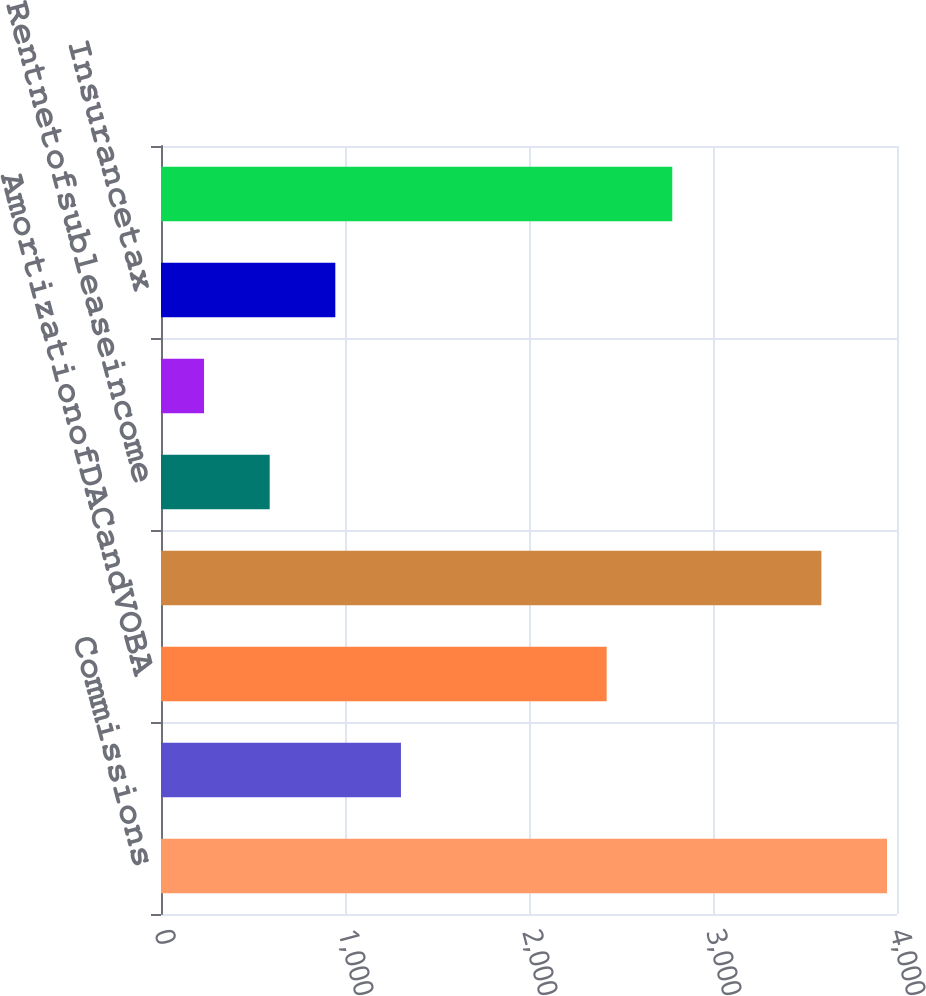Convert chart to OTSL. <chart><loc_0><loc_0><loc_500><loc_500><bar_chart><fcel>Commissions<fcel>Interestanddebtissuecosts<fcel>AmortizationofDACandVOBA<fcel>CapitalizationofDAC<fcel>Rentnetofsubleaseincome<fcel>Minorityinterest<fcel>Insurancetax<fcel>Other<nl><fcel>3945.7<fcel>1304.1<fcel>2422<fcel>3589<fcel>590.7<fcel>234<fcel>947.4<fcel>2778.7<nl></chart> 